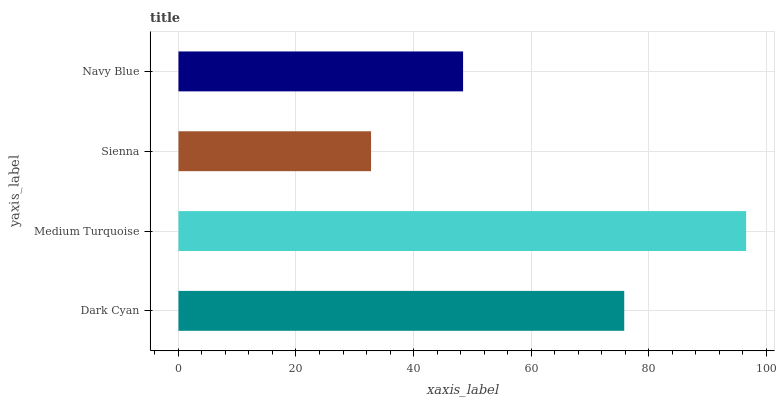Is Sienna the minimum?
Answer yes or no. Yes. Is Medium Turquoise the maximum?
Answer yes or no. Yes. Is Medium Turquoise the minimum?
Answer yes or no. No. Is Sienna the maximum?
Answer yes or no. No. Is Medium Turquoise greater than Sienna?
Answer yes or no. Yes. Is Sienna less than Medium Turquoise?
Answer yes or no. Yes. Is Sienna greater than Medium Turquoise?
Answer yes or no. No. Is Medium Turquoise less than Sienna?
Answer yes or no. No. Is Dark Cyan the high median?
Answer yes or no. Yes. Is Navy Blue the low median?
Answer yes or no. Yes. Is Sienna the high median?
Answer yes or no. No. Is Medium Turquoise the low median?
Answer yes or no. No. 